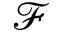<formula> <loc_0><loc_0><loc_500><loc_500>\mathcal { F }</formula> 